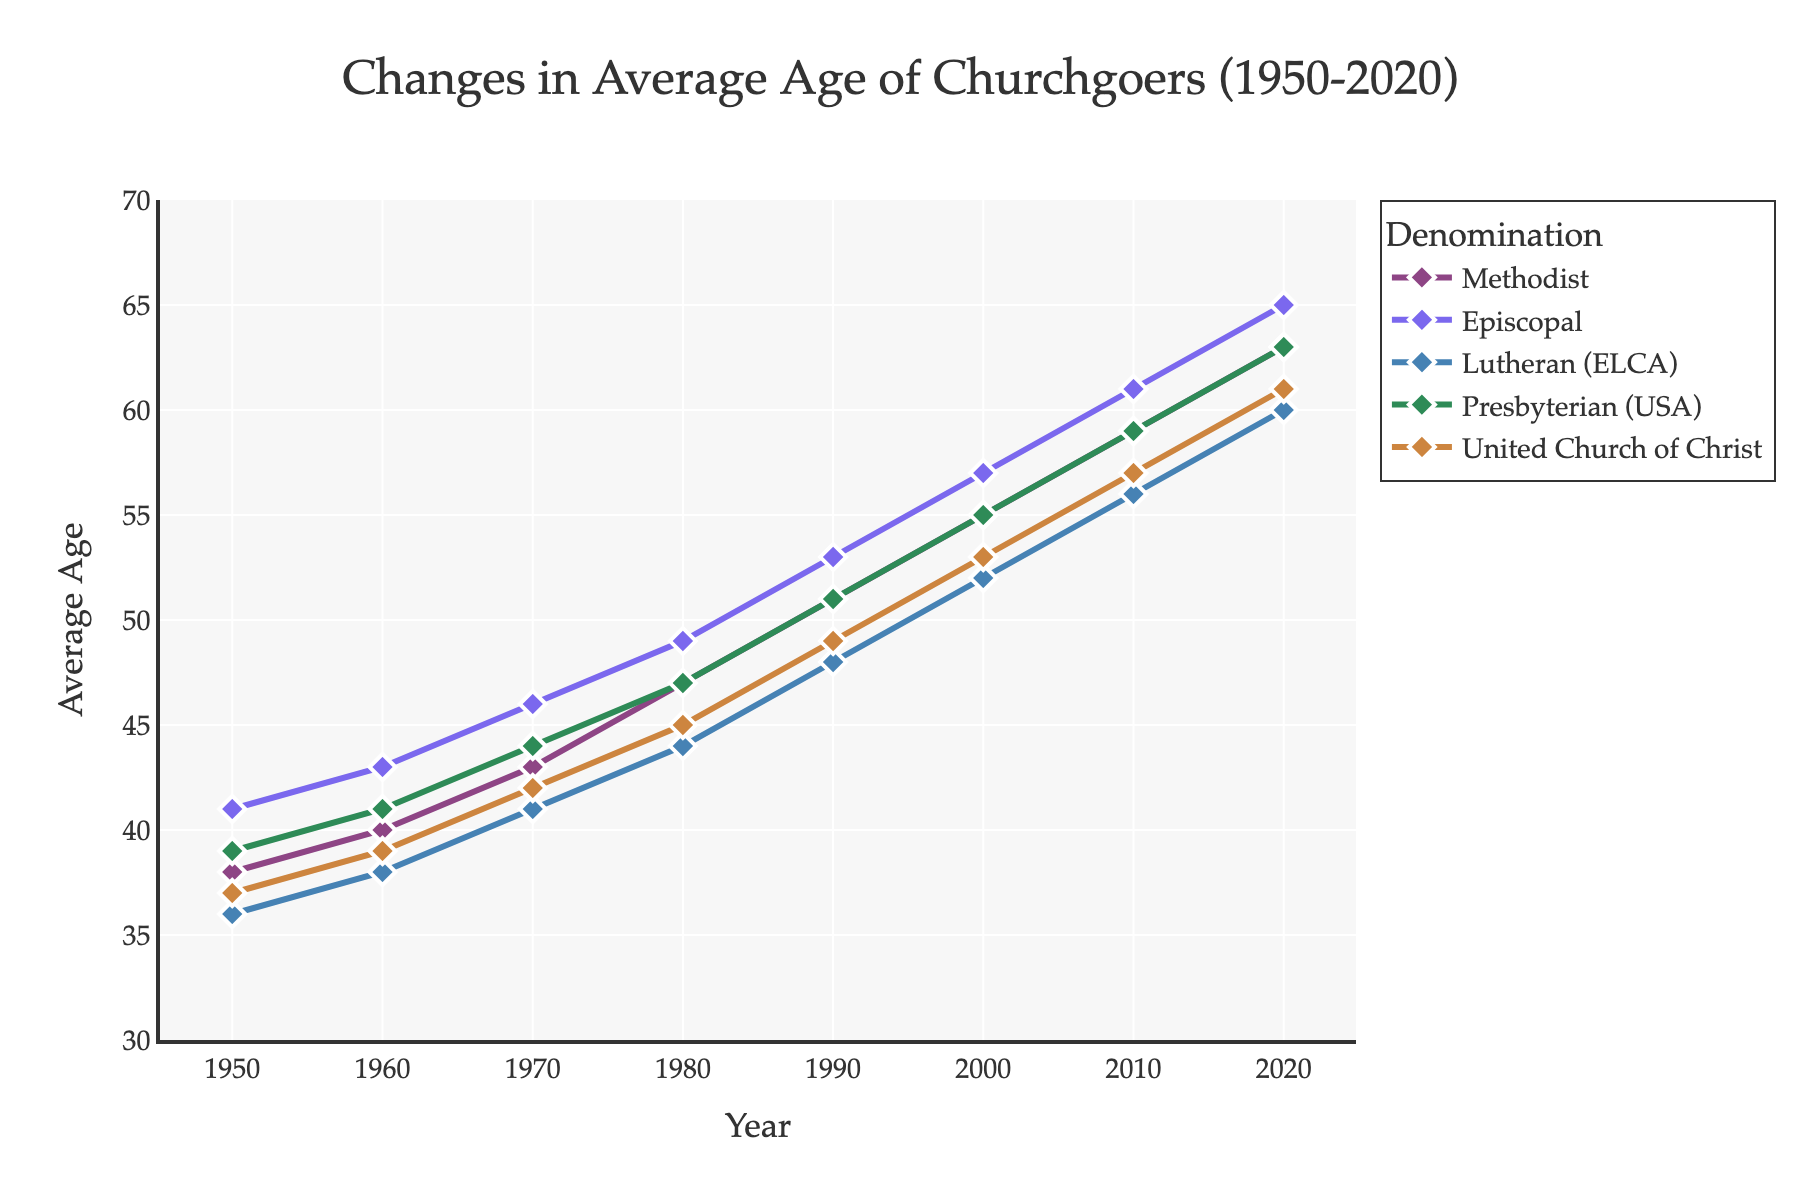Which denomination shows the highest average age in 2020? Looking at the end of the chart for the year 2020, the Episcopal denomination marks the highest average age.
Answer: Episcopal How did the average age of United Church of Christ members change from 1950 to 2020? Follow the line corresponding to United Church of Christ from 1950 to 2020; it increased from 37 to 61.
Answer: Increased by 24 years Is the average age of Presbyterian (USA) in 1990 higher or lower than the average age of Lutherans in 2010? Check the plot for Presbyterian (USA) in 1990 and Lutherans (ELCA) in 2010; Presbyterian has an average age of 51, whereas Lutherans have an average age of 56.
Answer: Lower Which denomination had the smallest increase in average age from 1950 to 2020? Calculate the increase for each denomination from 1950 to 2020 by subtracting the initial value from the final value: 
- Methodist: 63 - 38 = 25
- Episcopal: 65 - 41 = 24
- Lutheran (ELCA): 60 - 36 = 24
- Presbyterian (USA): 63 - 39 = 24
- United Church of Christ: 61 - 37 = 24
Episcopal, Lutheran (ELCA), Presbyterian (USA), and United Church of Christ all have the same increase.
Answer: Episcopal, Lutheran (ELCA), Presbyterian (USA), United Church of Christ When did the average age of Episcopal members first exceed 60? Look for the point where the Episcopal line crosses the 60-year mark, which happens in 2010.
Answer: 2010 What is the difference in the average age between Methodist and Lutheran (ELCA) denominations in 1970? Look at the year 1970 and subtract the average age of Lutheran (ELCA) from Methodist: 43 - 41.
Answer: 2 years How does the trend in average age of United Church of Christ compare to Presbyterian (USA) over the 70 years? Both denominations show a similar increasing trend with gradual steps up each decade, indicating a consistent rise in the average age.
Answer: Similar trend Which denomination had the steepest increase in average age during the 1980s? Calculate the increase for each denomination between 1980 and 1990:
- Methodist: 51 - 47 = 4
- Episcopal: 53 - 49 = 4
- Lutheran (ELCA): 48 - 44 = 4
- Presbyterian (USA): 51 - 47 = 4
- United Church of Christ: 49 - 45 = 4
All denominations had the same increase.
Answer: All Was the average age of any denomination ever below 35 after 1950? Follow the lines on the chart post-1950 to see if any denomination dips below 35; none do.
Answer: No 